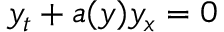<formula> <loc_0><loc_0><loc_500><loc_500>y _ { t } + a ( y ) y _ { x } = 0</formula> 